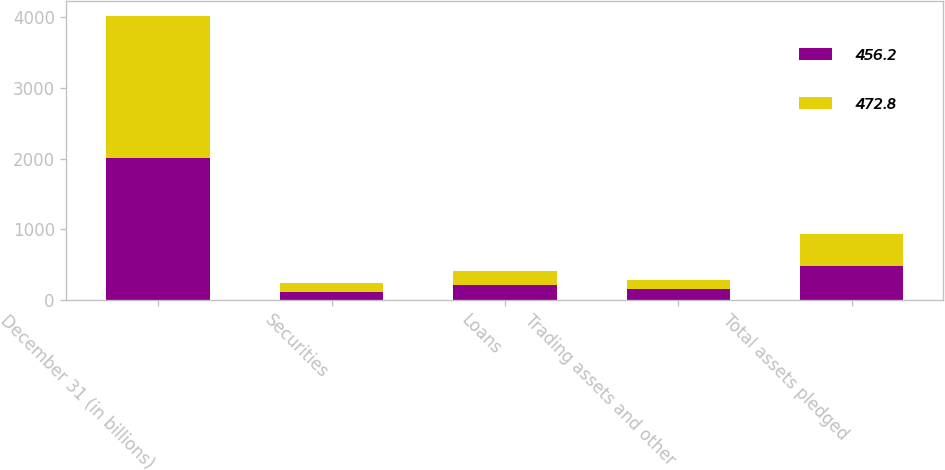<chart> <loc_0><loc_0><loc_500><loc_500><stacked_bar_chart><ecel><fcel>December 31 (in billions)<fcel>Securities<fcel>Loans<fcel>Trading assets and other<fcel>Total assets pledged<nl><fcel>456.2<fcel>2012<fcel>110.1<fcel>207.2<fcel>155.5<fcel>472.8<nl><fcel>472.8<fcel>2011<fcel>134.8<fcel>198.6<fcel>122.8<fcel>456.2<nl></chart> 